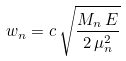Convert formula to latex. <formula><loc_0><loc_0><loc_500><loc_500>w _ { n } = c \, \sqrt { \frac { M _ { n } \, E } { 2 \, \mu _ { n } ^ { 2 } } } \,</formula> 